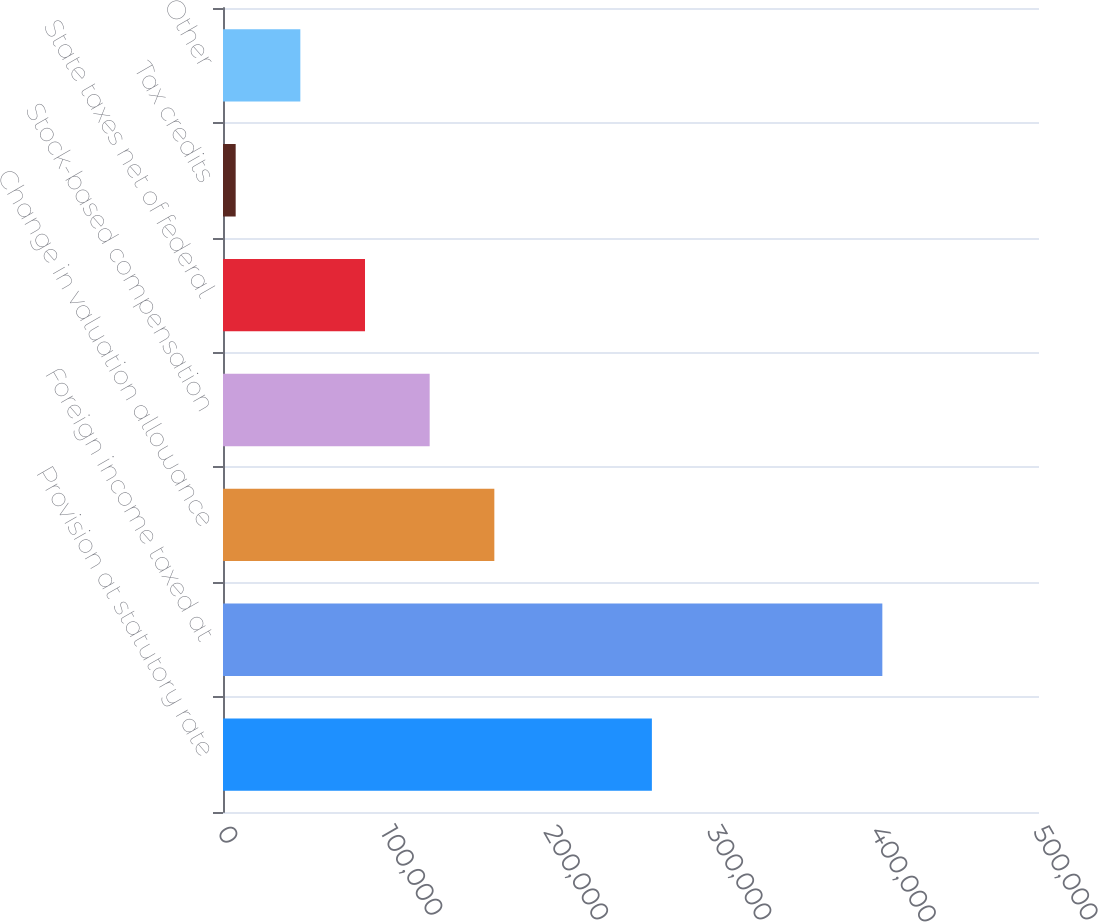<chart> <loc_0><loc_0><loc_500><loc_500><bar_chart><fcel>Provision at statutory rate<fcel>Foreign income taxed at<fcel>Change in valuation allowance<fcel>Stock-based compensation<fcel>State taxes net of federal<fcel>Tax credits<fcel>Other<nl><fcel>262798<fcel>404007<fcel>166262<fcel>126638<fcel>87014.2<fcel>7766<fcel>47390.1<nl></chart> 